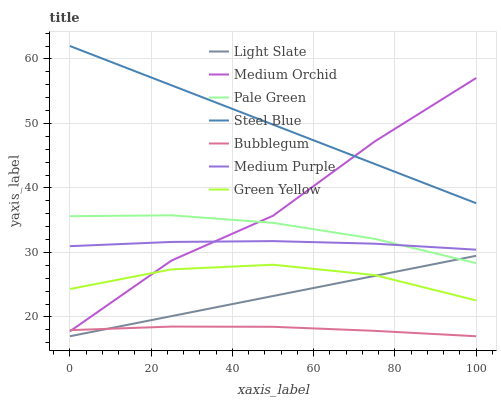Does Bubblegum have the minimum area under the curve?
Answer yes or no. Yes. Does Steel Blue have the maximum area under the curve?
Answer yes or no. Yes. Does Medium Orchid have the minimum area under the curve?
Answer yes or no. No. Does Medium Orchid have the maximum area under the curve?
Answer yes or no. No. Is Light Slate the smoothest?
Answer yes or no. Yes. Is Medium Orchid the roughest?
Answer yes or no. Yes. Is Steel Blue the smoothest?
Answer yes or no. No. Is Steel Blue the roughest?
Answer yes or no. No. Does Light Slate have the lowest value?
Answer yes or no. Yes. Does Medium Orchid have the lowest value?
Answer yes or no. No. Does Steel Blue have the highest value?
Answer yes or no. Yes. Does Medium Orchid have the highest value?
Answer yes or no. No. Is Bubblegum less than Steel Blue?
Answer yes or no. Yes. Is Pale Green greater than Bubblegum?
Answer yes or no. Yes. Does Green Yellow intersect Medium Orchid?
Answer yes or no. Yes. Is Green Yellow less than Medium Orchid?
Answer yes or no. No. Is Green Yellow greater than Medium Orchid?
Answer yes or no. No. Does Bubblegum intersect Steel Blue?
Answer yes or no. No. 